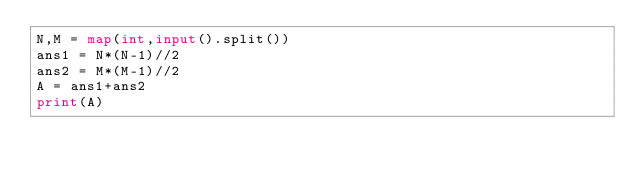<code> <loc_0><loc_0><loc_500><loc_500><_Python_>N,M = map(int,input().split())
ans1 = N*(N-1)//2
ans2 = M*(M-1)//2
A = ans1+ans2
print(A)</code> 